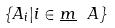<formula> <loc_0><loc_0><loc_500><loc_500>\{ A _ { i } | i \in \underline { m } \ A \}</formula> 